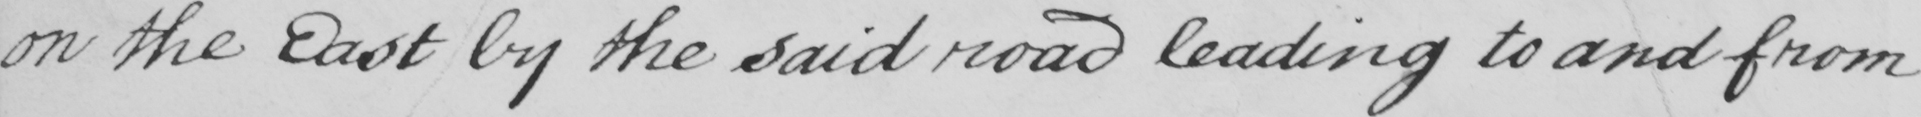Can you read and transcribe this handwriting? on the East by the said road leading to and from 